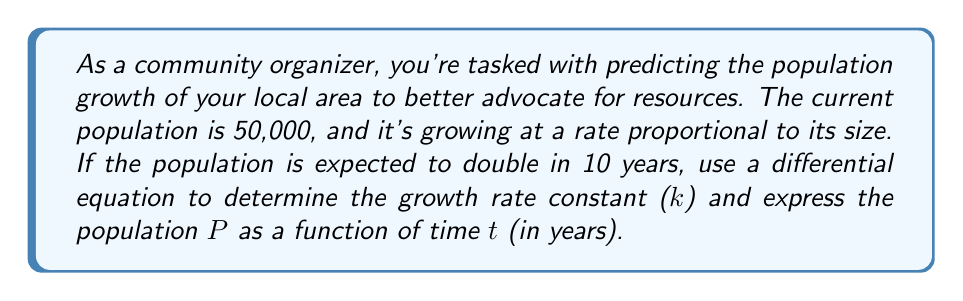Show me your answer to this math problem. Let's approach this step-by-step:

1) The differential equation for exponential population growth is:

   $$\frac{dP}{dt} = kP$$

   where P is the population, t is time, and k is the growth rate constant.

2) We can solve this differential equation:

   $$\int \frac{dP}{P} = \int k dt$$
   $$\ln P = kt + C$$
   $$P = e^{kt + C} = Ae^{kt}$$

   where A = e^C is the initial population.

3) We're given that P(0) = 50,000, so:

   $$50,000 = Ae^{k(0)} = A$$

4) We're also told that the population doubles in 10 years, so:

   $$P(10) = 2P(0) = 100,000 = 50,000e^{10k}$$

5) Solving for k:

   $$2 = e^{10k}$$
   $$\ln 2 = 10k$$
   $$k = \frac{\ln 2}{10} \approx 0.0693$$

6) Now we can express P as a function of t:

   $$P(t) = 50,000e^{0.0693t}$$

This equation gives us the population P at any time t (in years) after the initial measurement.
Answer: The growth rate constant k is approximately 0.0693 per year, and the population P as a function of time t (in years) is given by:

$$P(t) = 50,000e^{0.0693t}$$ 